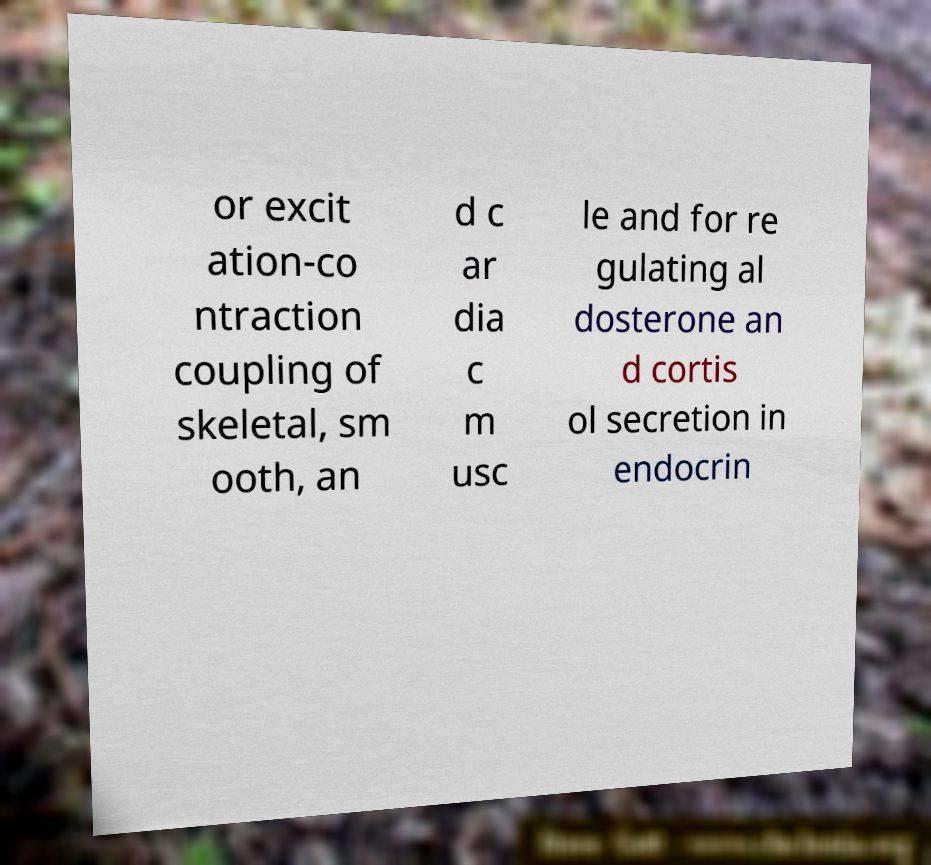What messages or text are displayed in this image? I need them in a readable, typed format. or excit ation-co ntraction coupling of skeletal, sm ooth, an d c ar dia c m usc le and for re gulating al dosterone an d cortis ol secretion in endocrin 